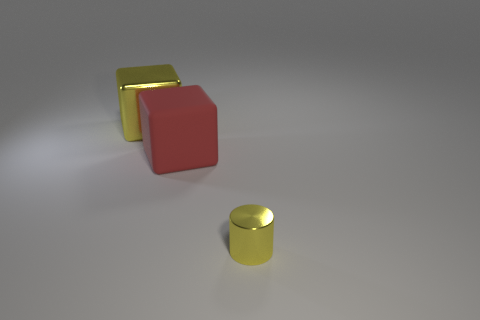How many rubber things are either large yellow cylinders or large yellow things?
Offer a very short reply. 0. What number of small brown metallic balls are there?
Keep it short and to the point. 0. What color is the other cube that is the same size as the red cube?
Keep it short and to the point. Yellow. Do the metal cube and the yellow cylinder have the same size?
Provide a short and direct response. No. What is the shape of the big metallic thing that is the same color as the small cylinder?
Provide a succinct answer. Cube. There is a yellow cylinder; is its size the same as the block that is behind the large red matte thing?
Provide a short and direct response. No. The object that is both in front of the large metal cube and on the left side of the yellow cylinder is what color?
Keep it short and to the point. Red. Is the number of large cubes behind the red matte cube greater than the number of yellow things that are left of the tiny shiny thing?
Your response must be concise. No. What size is the cube that is made of the same material as the tiny cylinder?
Your response must be concise. Large. There is a large red rubber block that is behind the yellow cylinder; what number of tiny metallic things are left of it?
Give a very brief answer. 0. 